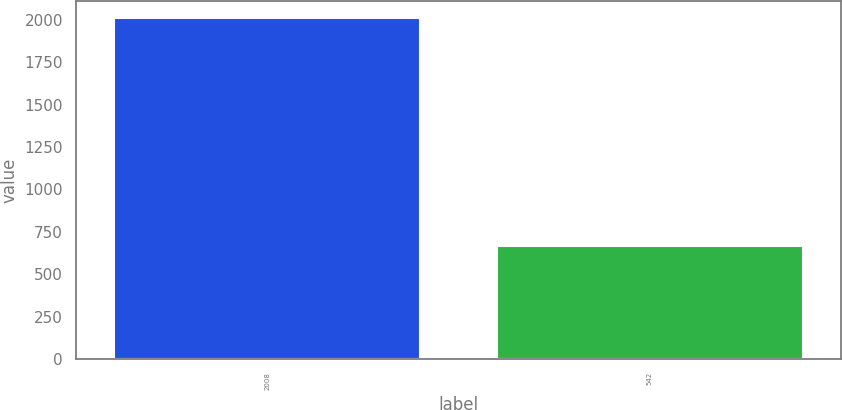Convert chart. <chart><loc_0><loc_0><loc_500><loc_500><bar_chart><fcel>2008<fcel>542<nl><fcel>2010<fcel>664<nl></chart> 